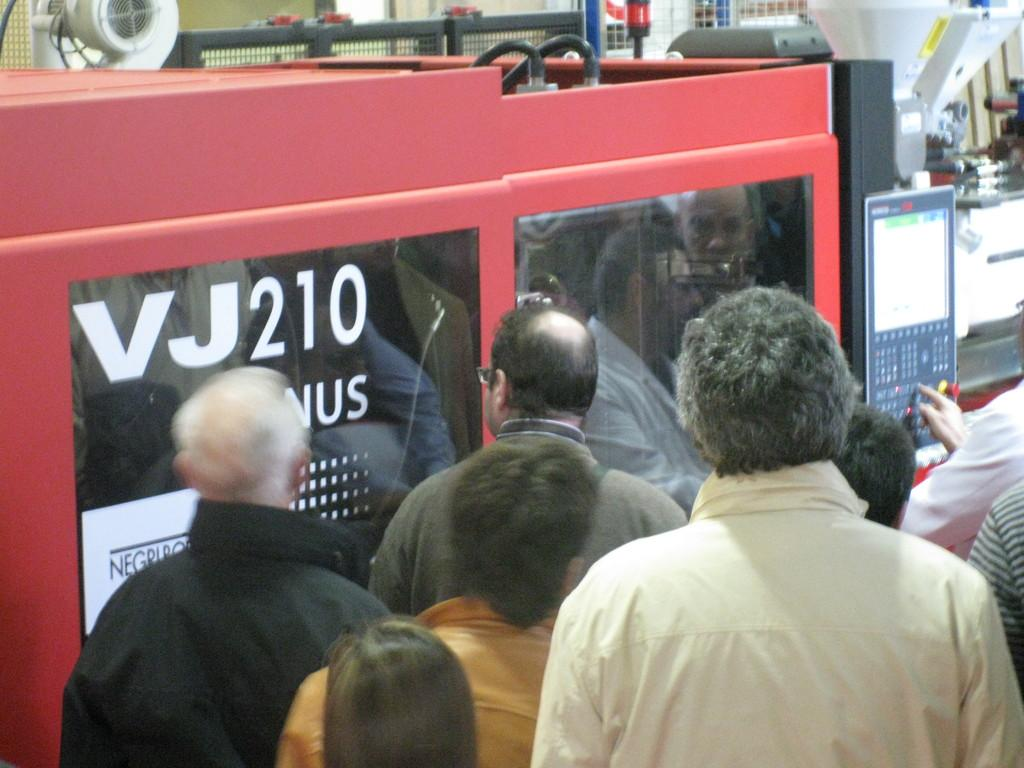What can be seen in the image? There are machines and people in the image. Can you describe the button in the image? There is a person's figure on a button in the image. What else can be seen in the background of the image? There are objects visible in the background of the image. What type of juice is being served in the image? There is no juice present in the image. How many turkeys are visible in the image? There are no turkeys visible in the image. 